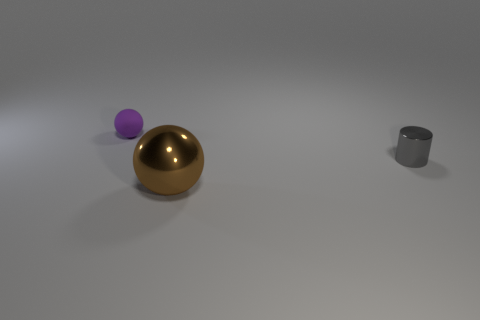What number of objects are either small matte spheres or tiny gray things?
Your response must be concise. 2. Do the metal object behind the large thing and the ball behind the small gray cylinder have the same size?
Your answer should be very brief. Yes. What number of spheres are either small gray shiny objects or small yellow matte objects?
Offer a very short reply. 0. Are there any metallic balls?
Ensure brevity in your answer.  Yes. Are there any other things that have the same shape as the large brown object?
Offer a terse response. Yes. Does the big sphere have the same color as the rubber object?
Offer a terse response. No. What number of things are either objects on the right side of the small rubber sphere or tiny metallic things?
Give a very brief answer. 2. There is a small thing in front of the purple matte ball behind the small cylinder; how many small things are behind it?
Give a very brief answer. 1. Are there any other things that are the same size as the metallic cylinder?
Give a very brief answer. Yes. What shape is the small thing to the left of the tiny thing right of the sphere that is in front of the purple ball?
Provide a short and direct response. Sphere. 